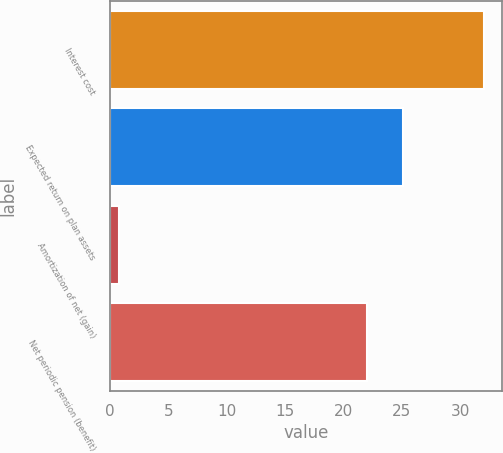<chart> <loc_0><loc_0><loc_500><loc_500><bar_chart><fcel>Interest cost<fcel>Expected return on plan assets<fcel>Amortization of net (gain)<fcel>Net periodic pension (benefit)<nl><fcel>32<fcel>25.12<fcel>0.8<fcel>22<nl></chart> 